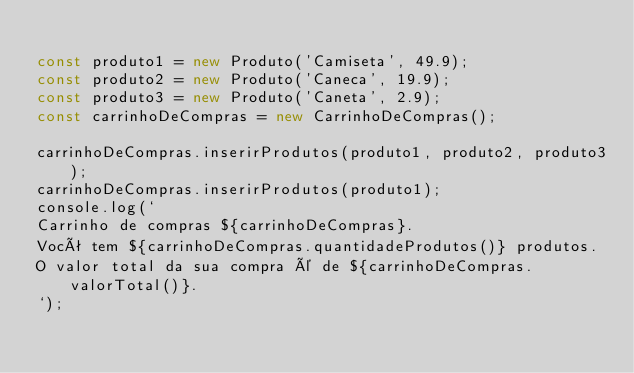<code> <loc_0><loc_0><loc_500><loc_500><_TypeScript_>
const produto1 = new Produto('Camiseta', 49.9);
const produto2 = new Produto('Caneca', 19.9);
const produto3 = new Produto('Caneta', 2.9);
const carrinhoDeCompras = new CarrinhoDeCompras();

carrinhoDeCompras.inserirProdutos(produto1, produto2, produto3);
carrinhoDeCompras.inserirProdutos(produto1);
console.log(`
Carrinho de compras ${carrinhoDeCompras}.
Você tem ${carrinhoDeCompras.quantidadeProdutos()} produtos.
O valor total da sua compra é de ${carrinhoDeCompras.valorTotal()}.
`);
</code> 